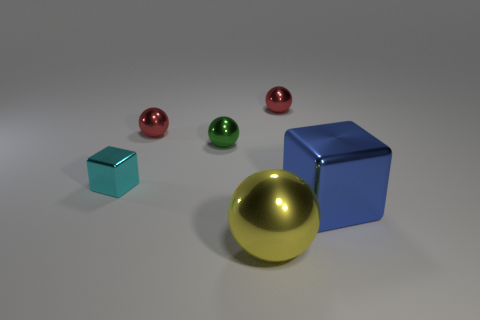How many objects are either balls to the right of the cyan block or big metal things that are in front of the blue shiny cube?
Make the answer very short. 4. There is a red sphere to the right of the tiny green metal object; what number of yellow metal spheres are left of it?
Provide a succinct answer. 1. There is another cube that is made of the same material as the tiny cube; what is its color?
Offer a very short reply. Blue. Are there any shiny things that have the same size as the green metallic ball?
Your answer should be very brief. Yes. What is the shape of the green metallic object that is the same size as the cyan shiny cube?
Ensure brevity in your answer.  Sphere. Is there a tiny red object of the same shape as the tiny cyan object?
Give a very brief answer. No. Is the material of the large yellow sphere the same as the big thing that is to the right of the yellow metallic sphere?
Give a very brief answer. Yes. Is there a object of the same color as the small block?
Make the answer very short. No. What number of other objects are there of the same material as the yellow object?
Offer a terse response. 5. There is a big metallic ball; is its color the same as the big thing behind the large yellow metallic sphere?
Keep it short and to the point. No. 